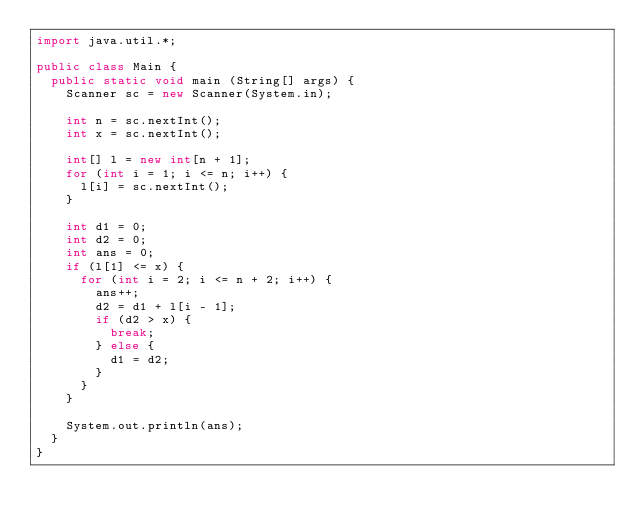<code> <loc_0><loc_0><loc_500><loc_500><_Java_>import java.util.*;

public class Main {
  public static void main (String[] args) {
    Scanner sc = new Scanner(System.in);

    int n = sc.nextInt();
    int x = sc.nextInt();

    int[] l = new int[n + 1];
    for (int i = 1; i <= n; i++) {
      l[i] = sc.nextInt();
    }

    int d1 = 0;
    int d2 = 0;
    int ans = 0;
    if (l[1] <= x) {
      for (int i = 2; i <= n + 2; i++) {
        ans++;
        d2 = d1 + l[i - 1];
        if (d2 > x) {
          break;
        } else {
          d1 = d2;
        }
      }
    }
    
    System.out.println(ans);
  }
}
</code> 